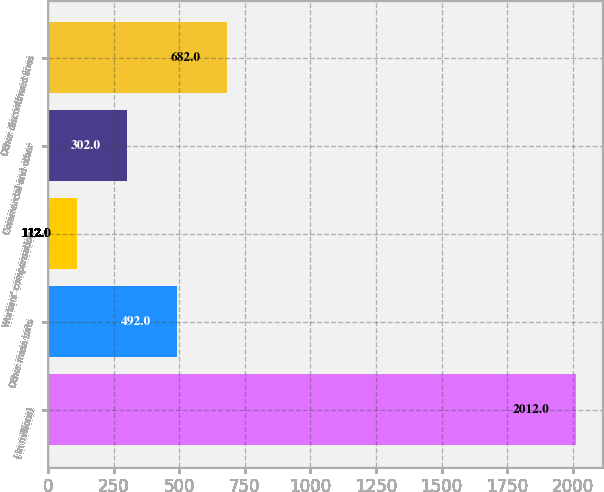<chart> <loc_0><loc_0><loc_500><loc_500><bar_chart><fcel>( in millions)<fcel>Other mass torts<fcel>Workers' compensation<fcel>Commercial and other<fcel>Other discontinued lines<nl><fcel>2012<fcel>492<fcel>112<fcel>302<fcel>682<nl></chart> 